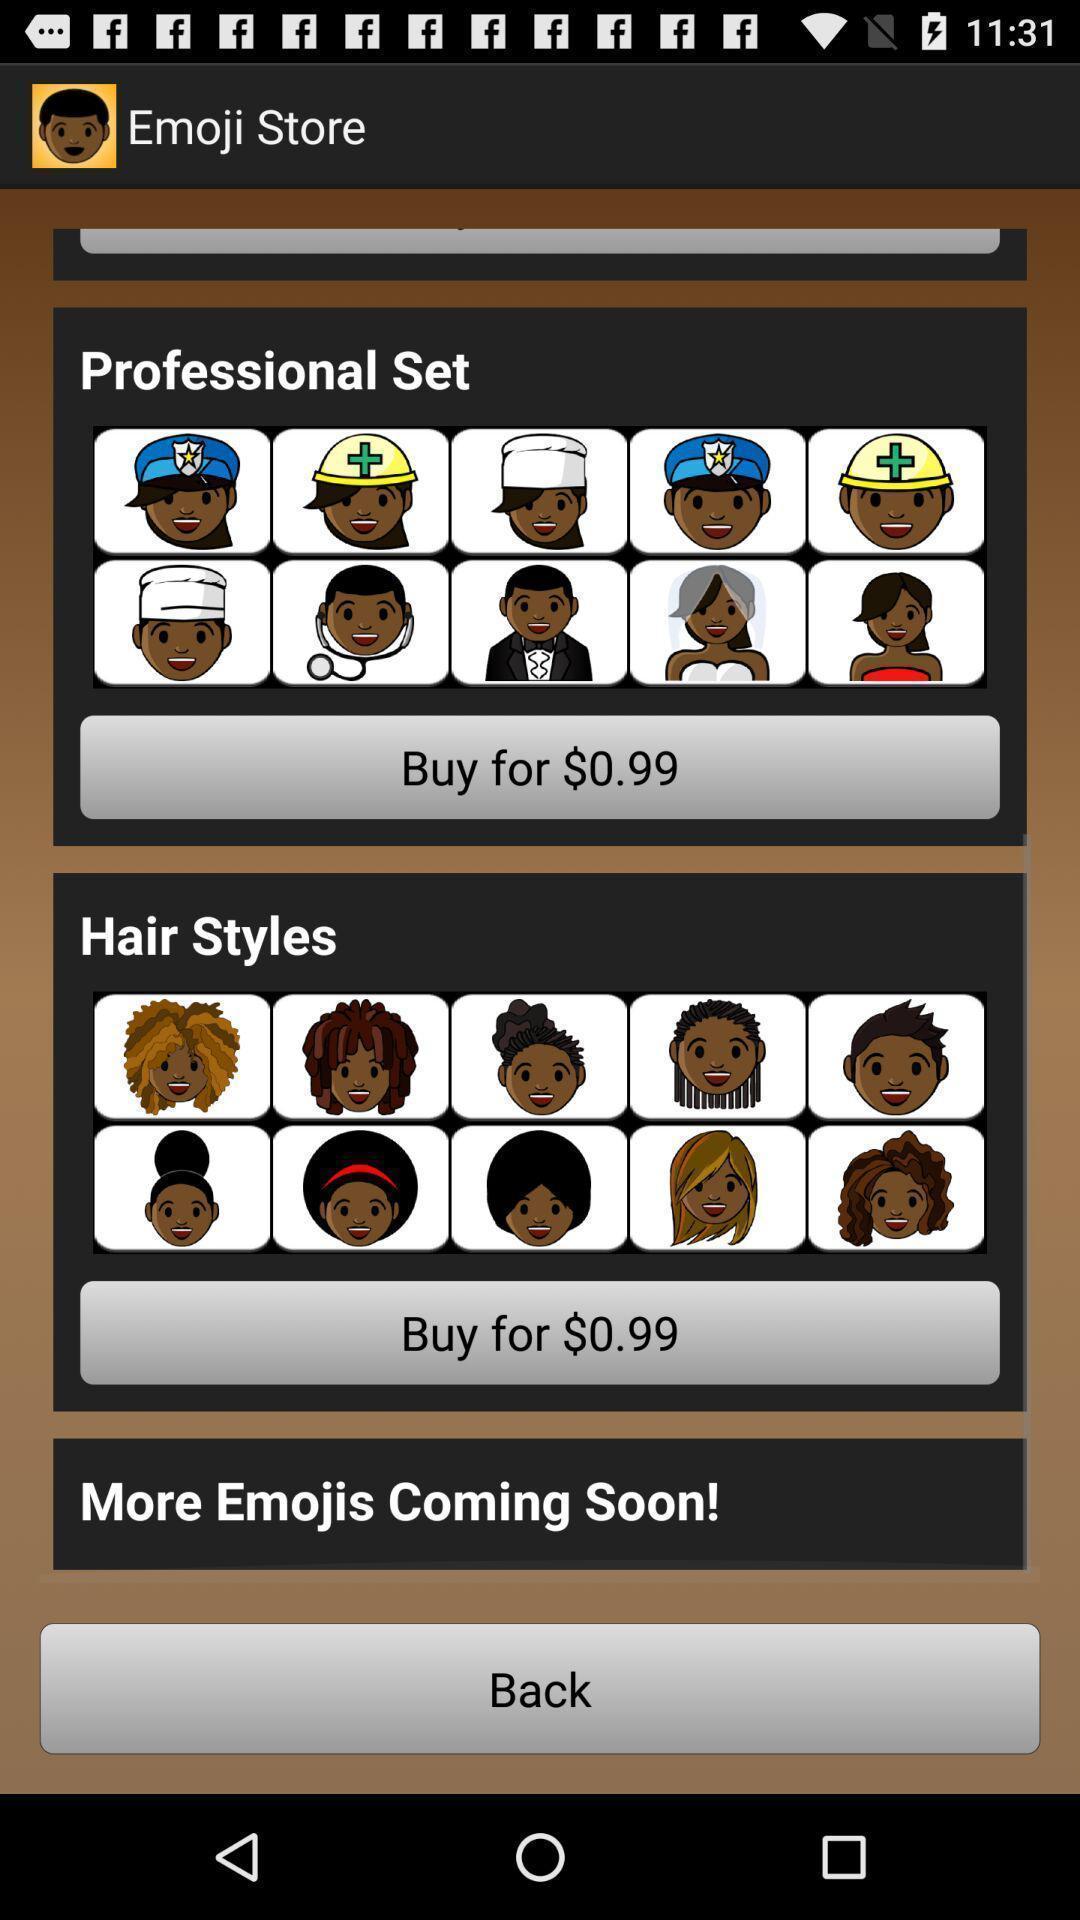Provide a description of this screenshot. Page showing the price of different emojis. 